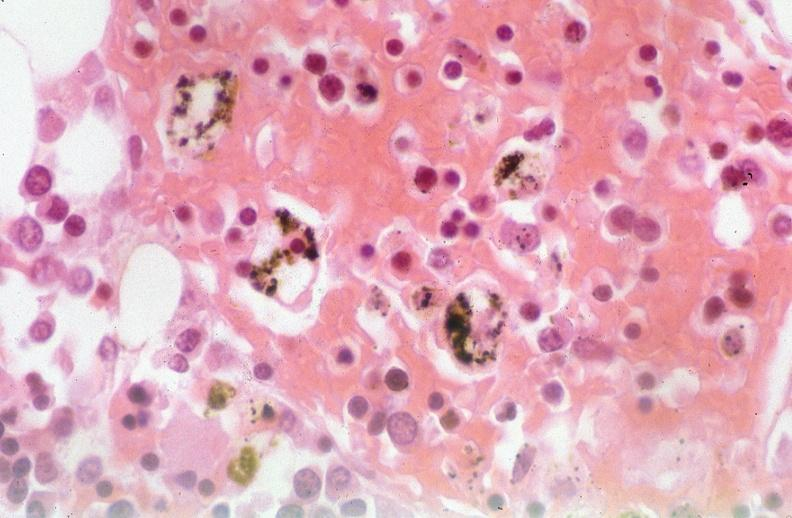s this partially fixed gross present?
Answer the question using a single word or phrase. No 